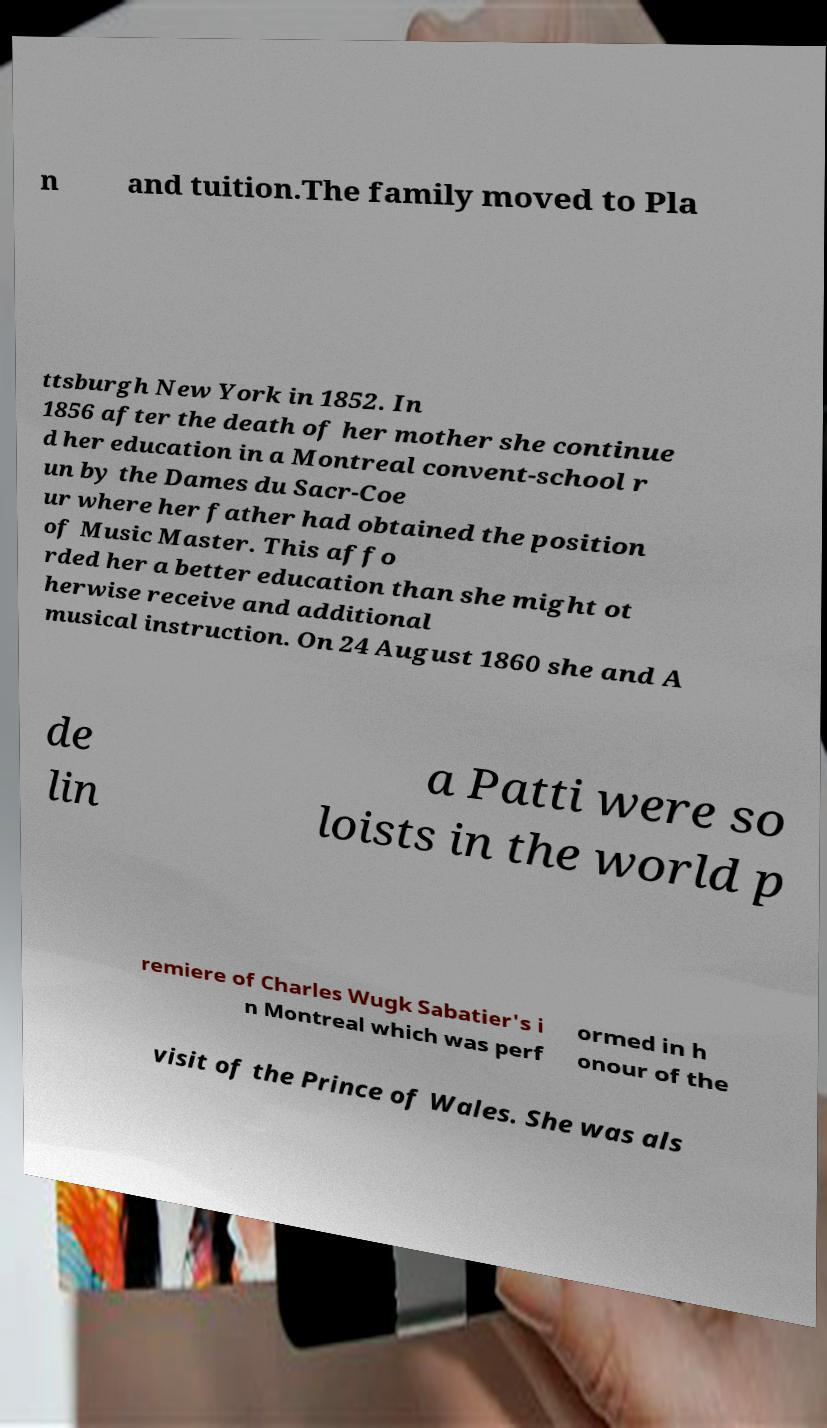Please identify and transcribe the text found in this image. n and tuition.The family moved to Pla ttsburgh New York in 1852. In 1856 after the death of her mother she continue d her education in a Montreal convent-school r un by the Dames du Sacr-Coe ur where her father had obtained the position of Music Master. This affo rded her a better education than she might ot herwise receive and additional musical instruction. On 24 August 1860 she and A de lin a Patti were so loists in the world p remiere of Charles Wugk Sabatier's i n Montreal which was perf ormed in h onour of the visit of the Prince of Wales. She was als 